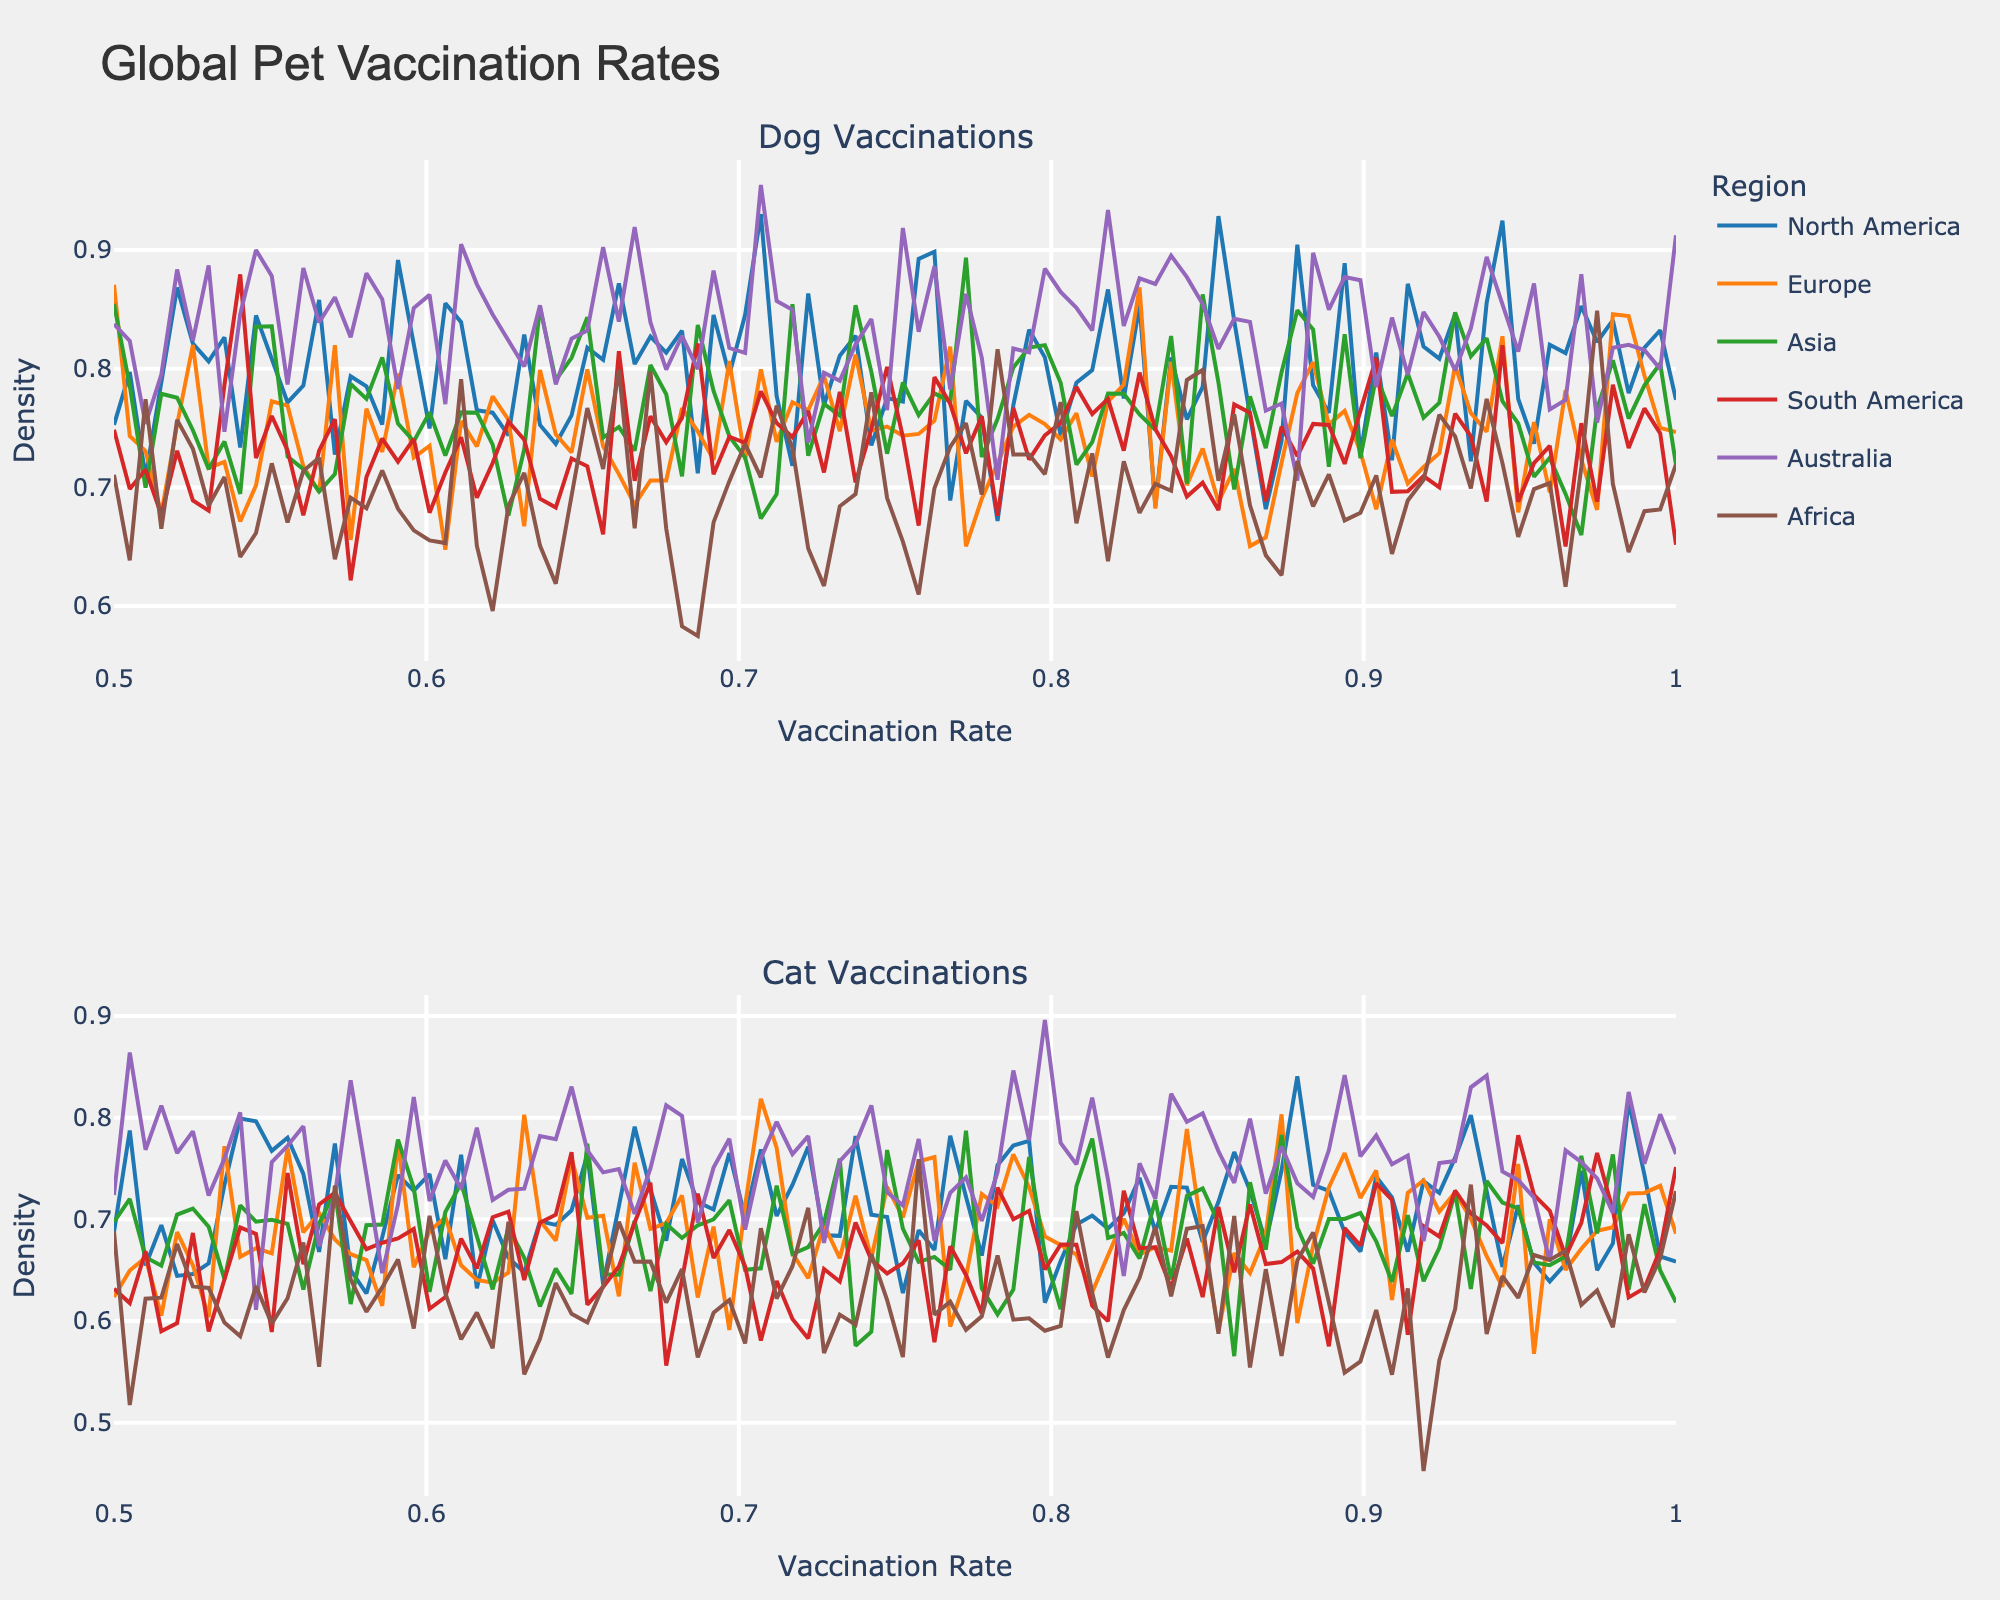what is the title of the figure? According to the visual information at the top of the figure, the title of the figure is clearly stated.
Answer: Global Pet Vaccination Rates What are the two subplot titles given in the figure? The subplot titles are visible above each plot within the figure. The first plot is titled "Dog Vaccinations" and the second is titled "Cat Vaccinations."
Answer: Dog Vaccinations, Cat Vaccinations Which region appears to have the highest average vaccination rate for dogs? By looking at the density plots in the "Dog Vaccinations" subplot, the color representing Australia (purple) reaches the highest point, indicating the highest density of vaccination rates.
Answer: Australia Compare the density at a vaccination rate of 0.7 for dogs between North America and Europe. Which has a higher density? By examining the densities along the x-axis at 0.7 in the "Dog Vaccinations" subplot, the density line for North America (blue) is higher than Europe (orange).
Answer: North America What is the range of the x-axis in the figure? The x-axis range can be determined by observing the values along the x-axis. The range is from 0.5 to 1.
Answer: 0.5 to 1 In which region is the density peak for cat rabies vaccination rates the highest? By analyzing the density peaks in the "Cat Vaccinations" subplot specifically for the color representing North America (blue), we can see that it has the highest peak for cat rabies vaccination rates.
Answer: North America Compare the cat DHPP vaccination rates between Asia and Africa. Which region has a greater average density? Observing the "Cat Vaccinations" subplot, the area under the curve for the color representing Asia (green) is generally higher compared to Africa (brown), indicating a greater average density.
Answer: Asia How do the vaccination rates for DHPP in dogs compare between South America and Africa? In the "Dog Vaccinations" subplot, compare the densities. South America (red) shows higher densities across most vaccination rate values than Africa (brown).
Answer: South America 